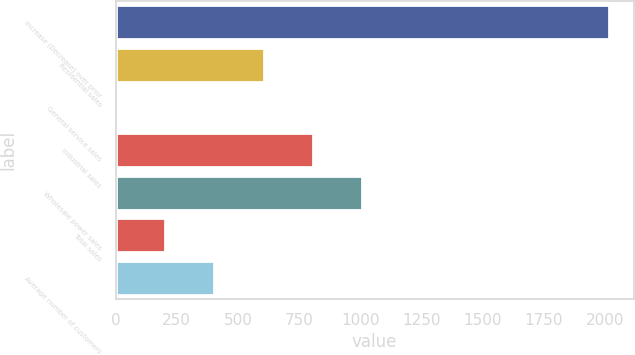<chart> <loc_0><loc_0><loc_500><loc_500><bar_chart><fcel>Increase (Decrease) over prior<fcel>Residential sales<fcel>General service sales<fcel>Industrial sales<fcel>Wholesale power sales<fcel>Total sales<fcel>Average number of customers<nl><fcel>2016<fcel>604.87<fcel>0.1<fcel>806.46<fcel>1008.05<fcel>201.69<fcel>403.28<nl></chart> 